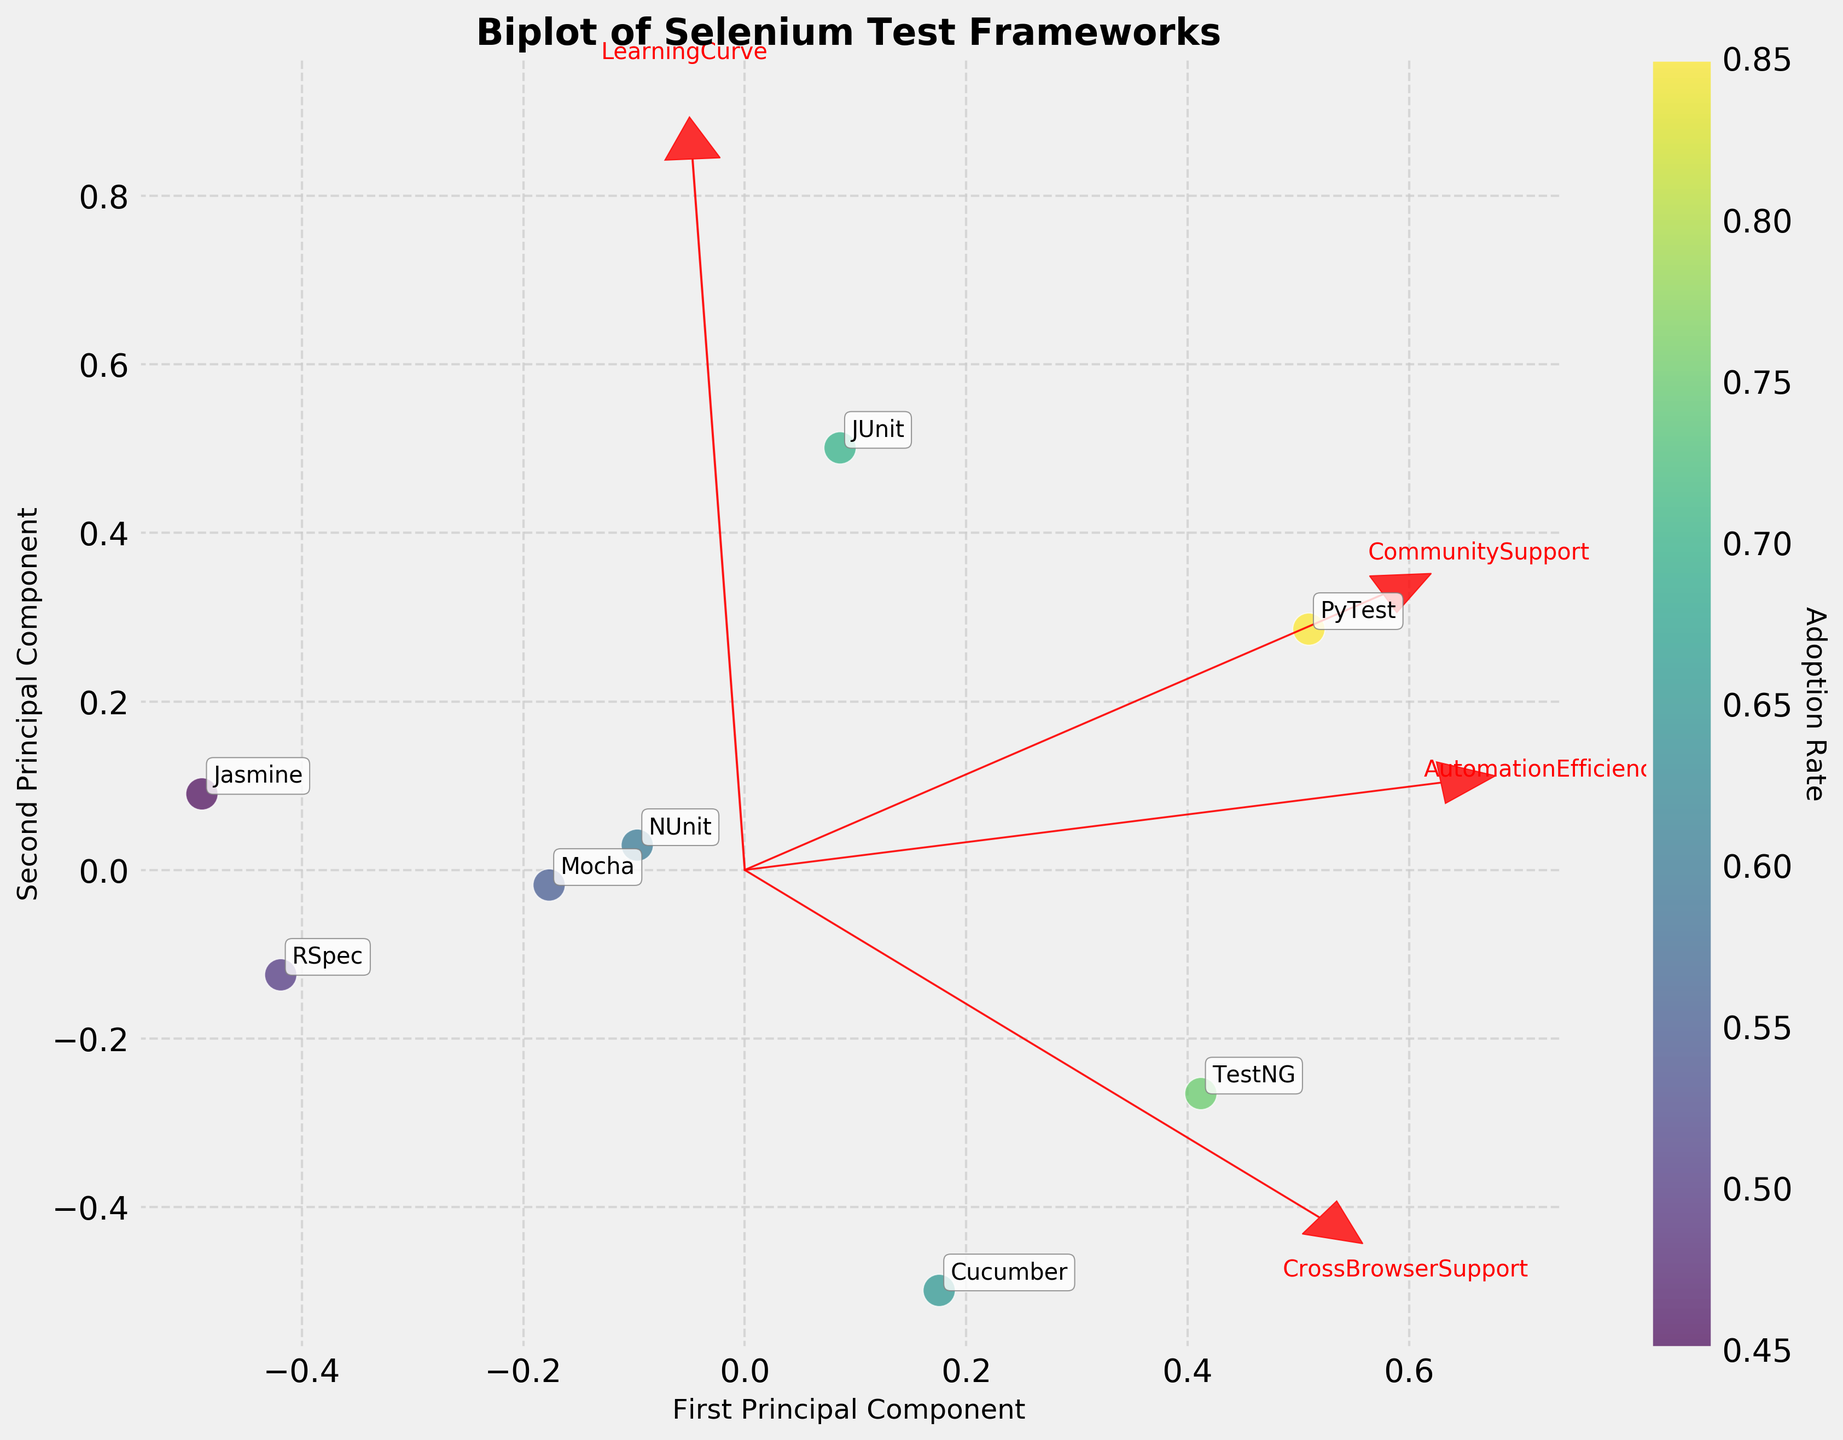Which test framework has the highest adoption rate? PyTest has the highest adoption rate, represented by deep yellow-green points which denote higher adoption rates on the color scale used in the figure.
Answer: PyTest What is the title of the figure? The title is prominently displayed at the top-center of the plot, indicating the purpose of the visualization.
Answer: Biplot of Selenium Test Frameworks Which feature vector is most closely aligned with the first principal component? The feature vector for 'AutomationEfficiency' points more horizontally to the right, indicating it is most aligned with the first principal component.
Answer: AutomationEfficiency Which test framework has the lowest adoption rate? Jasmine is positioned at the farthest end of the lower part of the colorbar, indicating the lowest adoption rate among the test frameworks.
Answer: Jasmine Between TestNG and Cucumber, which has a higher community support and what are their respective vectors pointing directions? TestNG's community support vector arrow points moderately to the upper-right, while Cucumber’s points a little lower comparatively. Therefore, TestNG has higher community support.
Answer: TestNG Which two features are closest in their projection directions on the biplot? By looking at the arrows' direction and their proximity, 'CommunitySupport' and 'CrossBrowserSupport' are closest in their directional projections.
Answer: CommunitySupport and CrossBrowserSupport How does NUnit compare to Mocha in terms of their positions on the biplot? NUnit is positioned slightly higher and more to the right than Mocha, suggesting it has relatively higher values for the first and second principal components.
Answer: NUnit is higher Which feature has the steepest learning curve as indicated by the figure? The arrow representing the 'LearningCurve' feature points significantly downward, representing a steep learning curve characteristic.
Answer: LearningCurve What color represents an adoption rate of 0.75 and which framework(s) fall at this adoption rate? The color for an adoption rate of 0.75 is a medium shade of yellow-green according to the color scale, and TestNG falls within this adoption rate.
Answer: TestNG Which test framework appears to balance the adoption rate, automation efficiency, and learning curve best according to the biplot? PyTest appears to maintain a balanced position with high adoption rate, automation efficiency, and a moderate learning curve, as indicated by its optimal spot relative to both the color scale and the PCA projection.
Answer: PyTest 